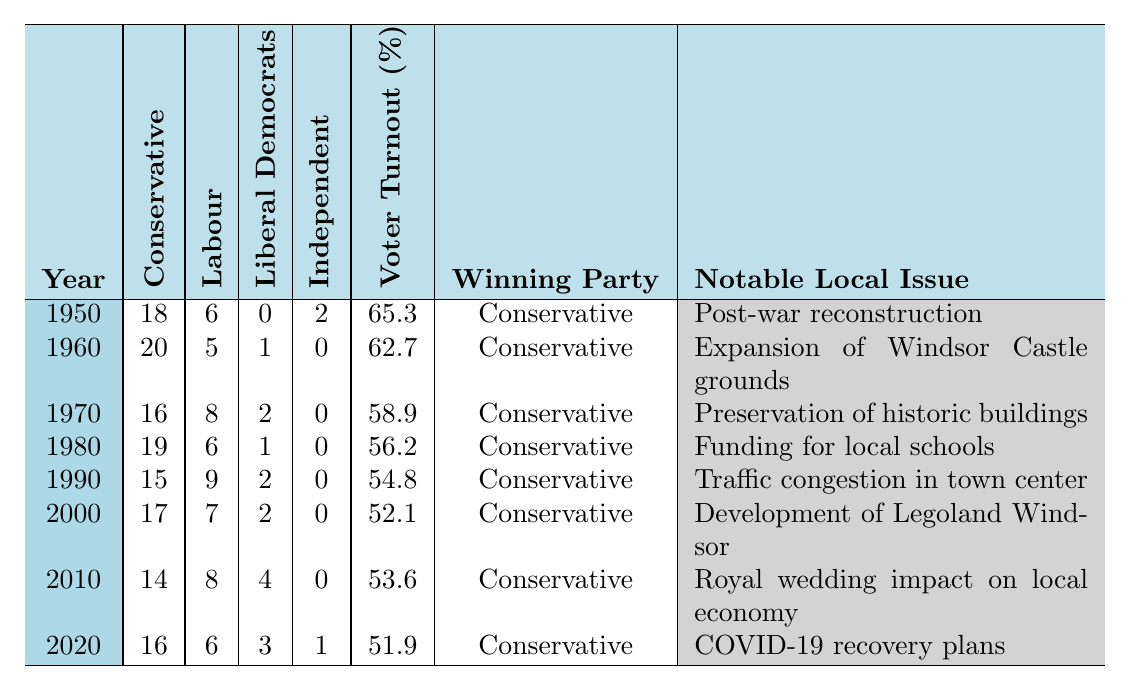What was the voter turnout percentage in 1980? The table lists the voter turnout percentage for each year. Looking at the row for 1980, the percentage is 56.2.
Answer: 56.2% Which party had the most seats in 1990? In the row for 1990, the Conservative Party had 15 seats, Labour had 9 seats, Liberal Democrats had 2 seats, and Independents had 0. The Conservative Party had the most seats.
Answer: Conservative Party What was the notable local issue for the elections in 2000? The row for 2000 states that the notable local issue was "Development of Legoland Windsor."
Answer: Development of Legoland Windsor Did the Labour Party seat count increase from 1970 to 1980? In 1970, the Labour Party had 8 seats, while in 1980, they had 6 seats. This means their seat count actually decreased.
Answer: No What is the total number of seats held by Liberal Democrats from 1950 to 2020? Summing the number of Liberal Democrats' seats over the years: 0 (1950) + 1 (1960) + 2 (1970) + 1 (1980) + 2 (1990) + 2 (2000) + 4 (2010) + 3 (2020) results in 15.
Answer: 15 In which year did the voter turnout fall below 55%? From the table, the only year where the voter turnout was below 55% is 2000 (52.1%) and 1990 (54.8%).
Answer: 2000 and 1990 What was the average number of Conservative seats held from 1950 to 2020? To find the average, add the Conservative seats: 18 + 20 + 16 + 19 + 15 + 17 + 14 + 16 = 135. Then divide by the number of years (8). Thus, 135/8 = 16.875, which rounds to 17.
Answer: 17 Was the winning party consistently the Conservative Party from 1950 to 2020? By examining each year, the winning party is listed as Conservative in all years provided, confirming the consistency.
Answer: Yes How many Independents were elected in 2020? In 2020, the table shows that there was 1 Independent seat.
Answer: 1 What was the notable local issue in the year with the lowest voter turnout? The lowest voter turnout was in 2000 (52.1%), where the notable local issue was "Development of Legoland Windsor."
Answer: Development of Legoland Windsor 